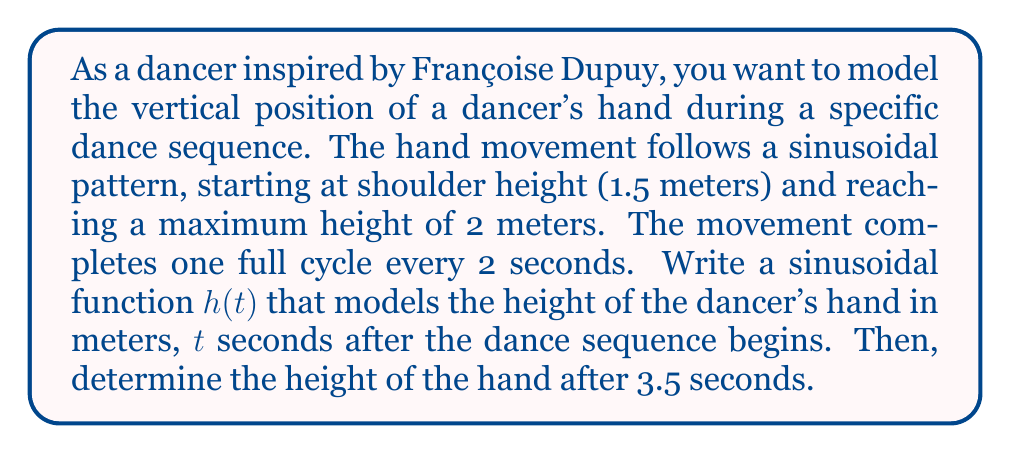Teach me how to tackle this problem. To model this periodic motion, we'll use a sine function in the form:

$$h(t) = A \sin(B(t - C)) + D$$

Where:
$A$ = amplitude
$B$ = angular frequency
$C$ = phase shift
$D$ = vertical shift

Step 1: Determine the amplitude ($A$)
The hand moves from 1.5m to 2m, so the total range is 0.5m. The amplitude is half of this:
$$A = \frac{0.5}{2} = 0.25$$

Step 2: Calculate the angular frequency ($B$)
The period is 2 seconds, so:
$$B = \frac{2\pi}{period} = \frac{2\pi}{2} = \pi$$

Step 3: Determine the phase shift ($C$)
The function starts at the middle of its range, so there's no phase shift:
$$C = 0$$

Step 4: Calculate the vertical shift ($D$)
The midpoint of the oscillation is:
$$D = 1.5 + 0.25 = 1.75$$

Step 5: Combine these values into the function:
$$h(t) = 0.25 \sin(\pi t) + 1.75$$

Step 6: To find the height at 3.5 seconds, substitute $t = 3.5$:
$$h(3.5) = 0.25 \sin(\pi(3.5)) + 1.75$$
$$= 0.25 \sin(3.5\pi) + 1.75$$
$$= 0.25(-1) + 1.75$$
$$= 1.5$$
Answer: The function modeling the hand's height is $h(t) = 0.25 \sin(\pi t) + 1.75$, where $h$ is in meters and $t$ is in seconds. After 3.5 seconds, the hand's height is 1.5 meters. 